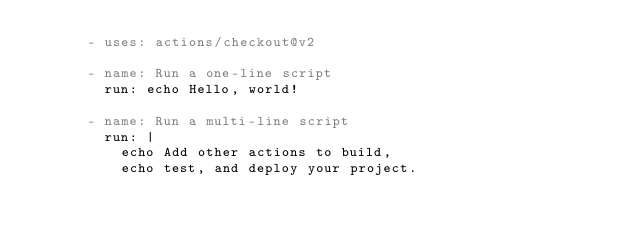Convert code to text. <code><loc_0><loc_0><loc_500><loc_500><_YAML_>      - uses: actions/checkout@v2

      - name: Run a one-line script
        run: echo Hello, world!

      - name: Run a multi-line script
        run: |
          echo Add other actions to build,
          echo test, and deploy your project.
</code> 